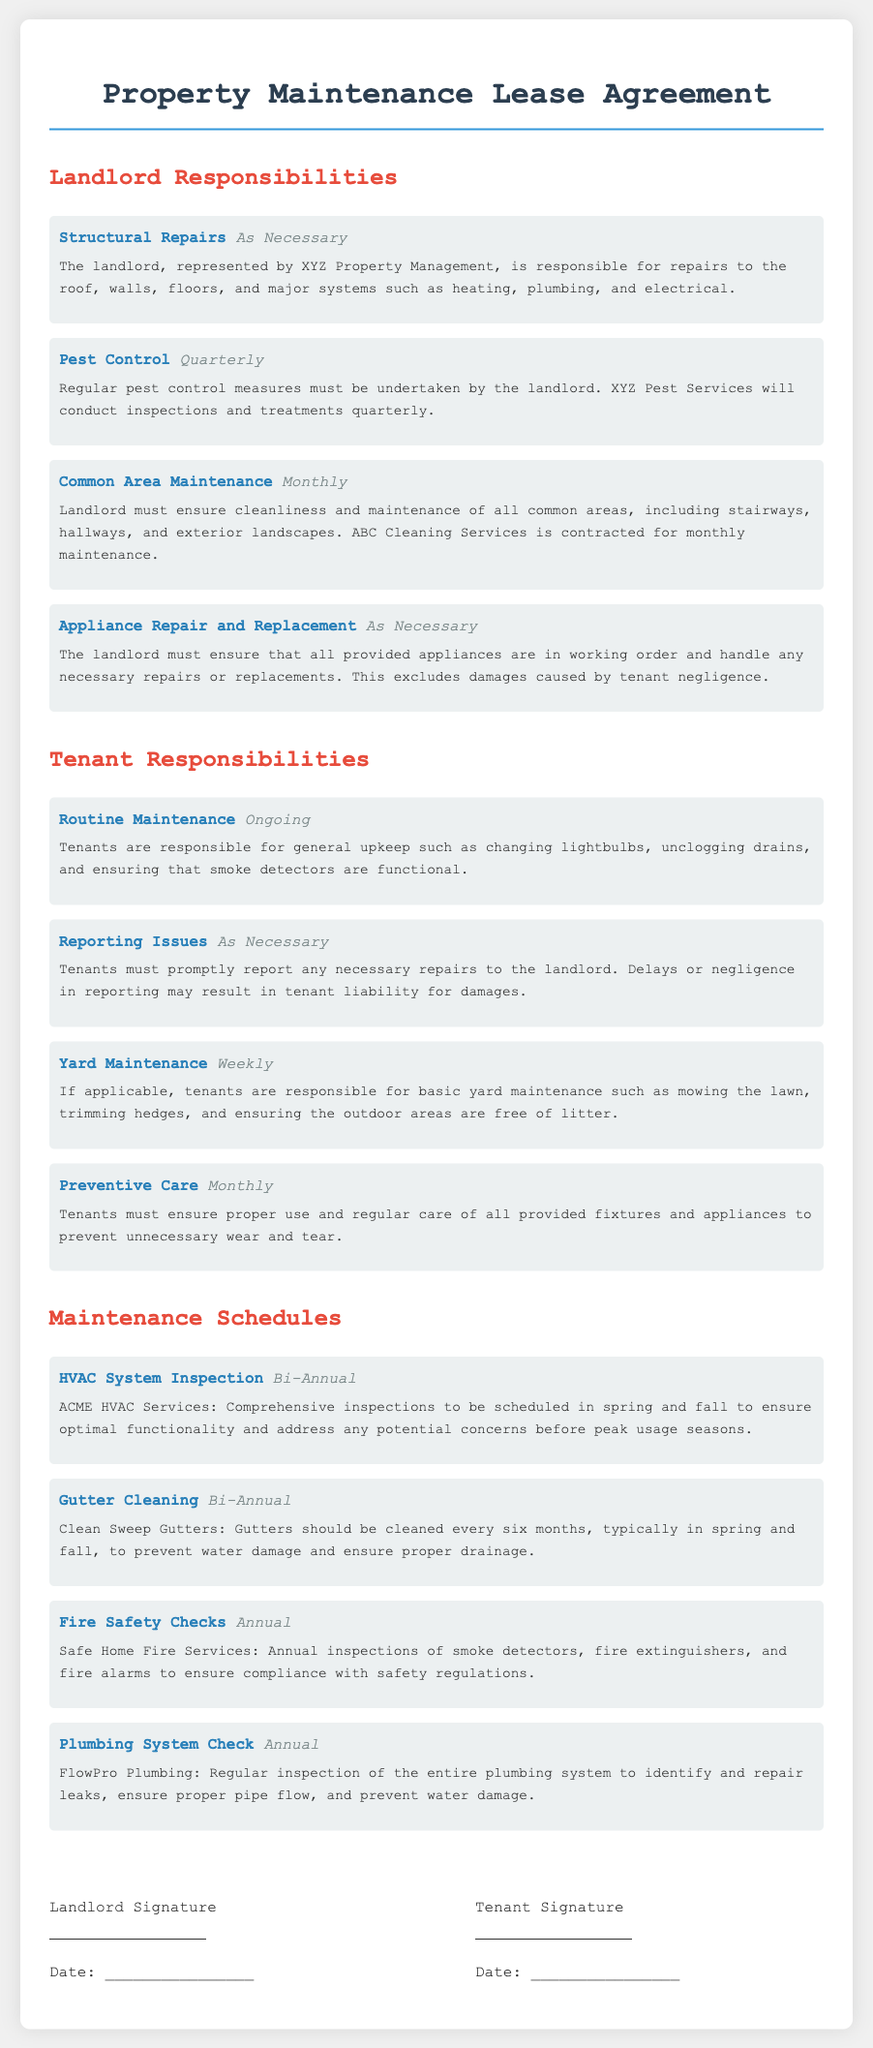What is the landlord's responsibility for pest control? The landlord is responsible for pest control measures, which must be undertaken quarterly.
Answer: Quarterly Who conducts regular pest control inspections? Regular pest control inspections and treatments will be conducted by XYZ Pest Services.
Answer: XYZ Pest Services How often must tenants perform yard maintenance? Tenants are responsible for basic yard maintenance weekly if applicable.
Answer: Weekly What is the frequency of HVAC system inspections? The HVAC system inspections are scheduled bi-annually in spring and fall.
Answer: Bi-Annual Which service is responsible for gutter cleaning? Clean Sweep Gutters is contracted for gutter cleaning services.
Answer: Clean Sweep Gutters What type of maintenance is the tenant responsible for ongoing? Tenants are responsible for routine maintenance such as changing lightbulbs and unclogging drains.
Answer: Ongoing If tenants delay reporting issues, what may result? Delays or negligence in reporting may result in tenant liability for damages.
Answer: Tenant liability What is the significance of Fire Safety Checks listed in the document? Fire Safety Checks are annual inspections to ensure compliance with safety regulations.
Answer: Compliance with safety regulations What are landlords required to ensure regarding appliances? The landlord must ensure that all provided appliances are in working order.
Answer: In working order 